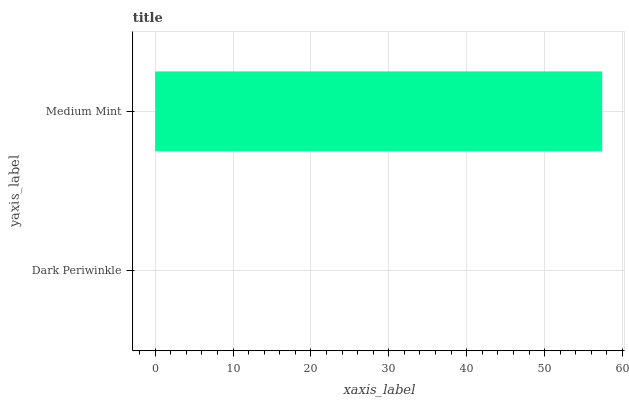Is Dark Periwinkle the minimum?
Answer yes or no. Yes. Is Medium Mint the maximum?
Answer yes or no. Yes. Is Medium Mint the minimum?
Answer yes or no. No. Is Medium Mint greater than Dark Periwinkle?
Answer yes or no. Yes. Is Dark Periwinkle less than Medium Mint?
Answer yes or no. Yes. Is Dark Periwinkle greater than Medium Mint?
Answer yes or no. No. Is Medium Mint less than Dark Periwinkle?
Answer yes or no. No. Is Medium Mint the high median?
Answer yes or no. Yes. Is Dark Periwinkle the low median?
Answer yes or no. Yes. Is Dark Periwinkle the high median?
Answer yes or no. No. Is Medium Mint the low median?
Answer yes or no. No. 